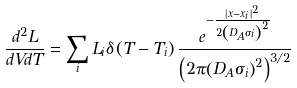Convert formula to latex. <formula><loc_0><loc_0><loc_500><loc_500>\frac { d ^ { 2 } L } { d V d T } = \sum _ { i } L _ { i } \delta \left ( T - T _ { i } \right ) \frac { e ^ { - \frac { \left | { { x } - { x _ { i } } } \right | ^ { 2 } } { 2 { \left ( D _ { A } \sigma _ { i } \right ) } ^ { 2 } } } } { \left ( 2 \pi { \left ( D _ { A } \sigma _ { i } \right ) } ^ { 2 } \right ) ^ { 3 / 2 } }</formula> 